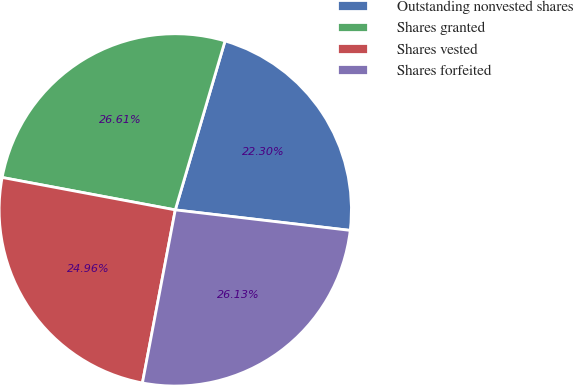Convert chart. <chart><loc_0><loc_0><loc_500><loc_500><pie_chart><fcel>Outstanding nonvested shares<fcel>Shares granted<fcel>Shares vested<fcel>Shares forfeited<nl><fcel>22.3%<fcel>26.61%<fcel>24.96%<fcel>26.13%<nl></chart> 